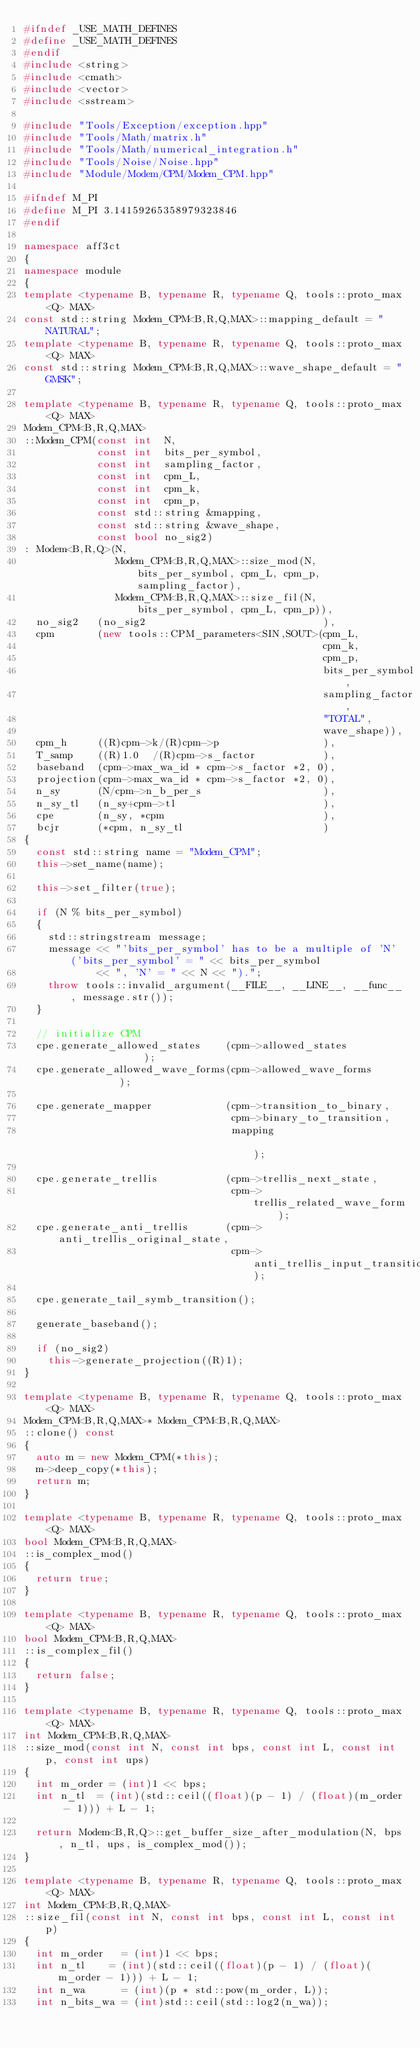<code> <loc_0><loc_0><loc_500><loc_500><_C++_>#ifndef _USE_MATH_DEFINES
#define _USE_MATH_DEFINES
#endif
#include <string>
#include <cmath>
#include <vector>
#include <sstream>

#include "Tools/Exception/exception.hpp"
#include "Tools/Math/matrix.h"
#include "Tools/Math/numerical_integration.h"
#include "Tools/Noise/Noise.hpp"
#include "Module/Modem/CPM/Modem_CPM.hpp"

#ifndef M_PI
#define M_PI 3.14159265358979323846
#endif

namespace aff3ct
{
namespace module
{
template <typename B, typename R, typename Q, tools::proto_max<Q> MAX>
const std::string Modem_CPM<B,R,Q,MAX>::mapping_default = "NATURAL";
template <typename B, typename R, typename Q, tools::proto_max<Q> MAX>
const std::string Modem_CPM<B,R,Q,MAX>::wave_shape_default = "GMSK";

template <typename B, typename R, typename Q, tools::proto_max<Q> MAX>
Modem_CPM<B,R,Q,MAX>
::Modem_CPM(const int  N,
            const int  bits_per_symbol,
            const int  sampling_factor,
            const int  cpm_L,
            const int  cpm_k,
            const int  cpm_p,
            const std::string &mapping,
            const std::string &wave_shape,
            const bool no_sig2)
: Modem<B,R,Q>(N,
               Modem_CPM<B,R,Q,MAX>::size_mod(N, bits_per_symbol, cpm_L, cpm_p, sampling_factor),
               Modem_CPM<B,R,Q,MAX>::size_fil(N, bits_per_symbol, cpm_L, cpm_p)),
  no_sig2   (no_sig2                             ),
  cpm       (new tools::CPM_parameters<SIN,SOUT>(cpm_L,
                                                 cpm_k,
                                                 cpm_p,
                                                 bits_per_symbol,
                                                 sampling_factor,
                                                 "TOTAL",
                                                 wave_shape)),
  cpm_h     ((R)cpm->k/(R)cpm->p                 ),
  T_samp    ((R)1.0  /(R)cpm->s_factor           ),
  baseband  (cpm->max_wa_id * cpm->s_factor *2, 0),
  projection(cpm->max_wa_id * cpm->s_factor *2, 0),
  n_sy      (N/cpm->n_b_per_s                    ),
  n_sy_tl   (n_sy+cpm->tl                        ),
  cpe       (n_sy, *cpm                          ),
  bcjr      (*cpm, n_sy_tl                       )
{
	const std::string name = "Modem_CPM";
	this->set_name(name);

	this->set_filter(true);

	if (N % bits_per_symbol)
	{
		std::stringstream message;
		message << "'bits_per_symbol' has to be a multiple of 'N' ('bits_per_symbol' = " << bits_per_symbol
		        << ", 'N' = " << N << ").";
		throw tools::invalid_argument(__FILE__, __LINE__, __func__, message.str());
	}

	// initialize CPM
	cpe.generate_allowed_states    (cpm->allowed_states               );
	cpe.generate_allowed_wave_forms(cpm->allowed_wave_forms           );

	cpe.generate_mapper            (cpm->transition_to_binary,
	                                cpm->binary_to_transition,
	                                mapping                           );

	cpe.generate_trellis           (cpm->trellis_next_state,
	                                cpm->trellis_related_wave_form    );
	cpe.generate_anti_trellis      (cpm->anti_trellis_original_state,
	                                cpm->anti_trellis_input_transition);

	cpe.generate_tail_symb_transition();

	generate_baseband();

	if (no_sig2)
		this->generate_projection((R)1);
}

template <typename B, typename R, typename Q, tools::proto_max<Q> MAX>
Modem_CPM<B,R,Q,MAX>* Modem_CPM<B,R,Q,MAX>
::clone() const
{
	auto m = new Modem_CPM(*this);
	m->deep_copy(*this);
	return m;
}

template <typename B, typename R, typename Q, tools::proto_max<Q> MAX>
bool Modem_CPM<B,R,Q,MAX>
::is_complex_mod()
{
	return true;
}

template <typename B, typename R, typename Q, tools::proto_max<Q> MAX>
bool Modem_CPM<B,R,Q,MAX>
::is_complex_fil()
{
	return false;
}

template <typename B, typename R, typename Q, tools::proto_max<Q> MAX>
int Modem_CPM<B,R,Q,MAX>
::size_mod(const int N, const int bps, const int L, const int p, const int ups)
{
	int m_order = (int)1 << bps;
	int n_tl	= (int)(std::ceil((float)(p - 1) / (float)(m_order - 1))) + L - 1;

	return Modem<B,R,Q>::get_buffer_size_after_modulation(N, bps, n_tl, ups, is_complex_mod());
}

template <typename B, typename R, typename Q, tools::proto_max<Q> MAX>
int Modem_CPM<B,R,Q,MAX>
::size_fil(const int N, const int bps, const int L, const int p)
{
	int m_order   = (int)1 << bps;
	int n_tl	  = (int)(std::ceil((float)(p - 1) / (float)(m_order - 1))) + L - 1;
	int n_wa      = (int)(p * std::pow(m_order, L));
	int n_bits_wa = (int)std::ceil(std::log2(n_wa));</code> 